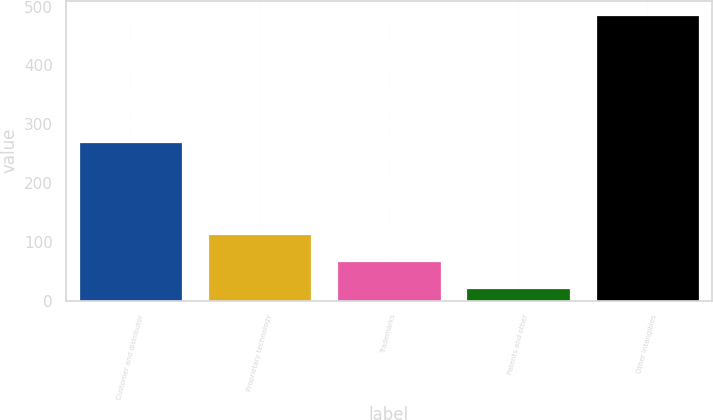Convert chart. <chart><loc_0><loc_0><loc_500><loc_500><bar_chart><fcel>Customer and distributor<fcel>Proprietary technology<fcel>Trademarks<fcel>Patents and other<fcel>Other intangibles<nl><fcel>270<fcel>113.8<fcel>67.4<fcel>21<fcel>485<nl></chart> 